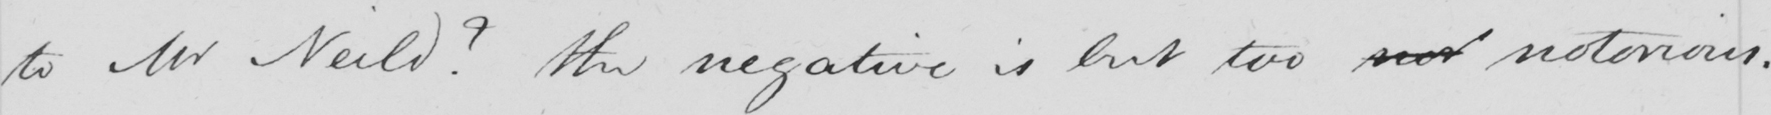Please provide the text content of this handwritten line. to Mr Neild ?  The negative is but too nor notorious . 